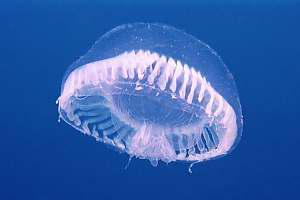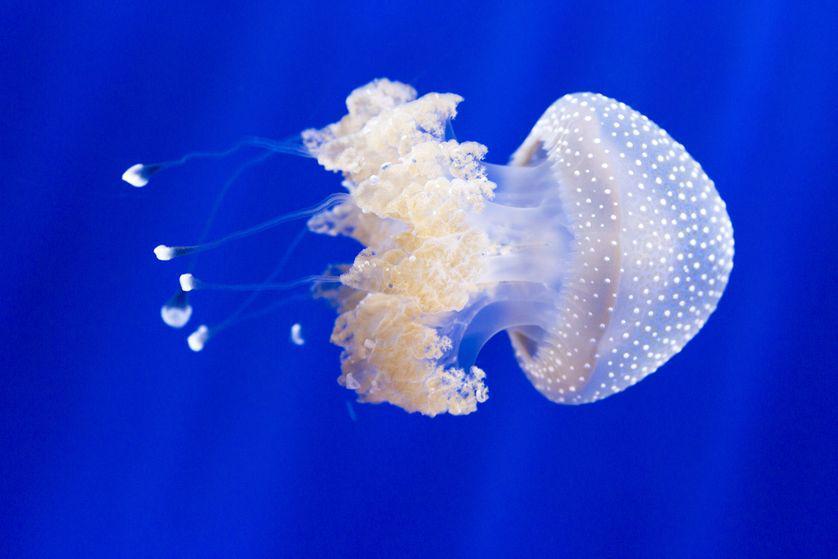The first image is the image on the left, the second image is the image on the right. Analyze the images presented: Is the assertion "A single white jellyfish is traveling towards the right in one of the images." valid? Answer yes or no. Yes. The first image is the image on the left, the second image is the image on the right. Considering the images on both sides, is "An image shows a white jellyfish with its 'mushroom cap' heading rightward." valid? Answer yes or no. Yes. 